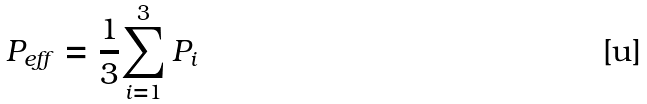<formula> <loc_0><loc_0><loc_500><loc_500>P _ { e f f } = \frac { 1 } { 3 } { \sum _ { i = 1 } ^ { 3 } { P _ { i } } }</formula> 